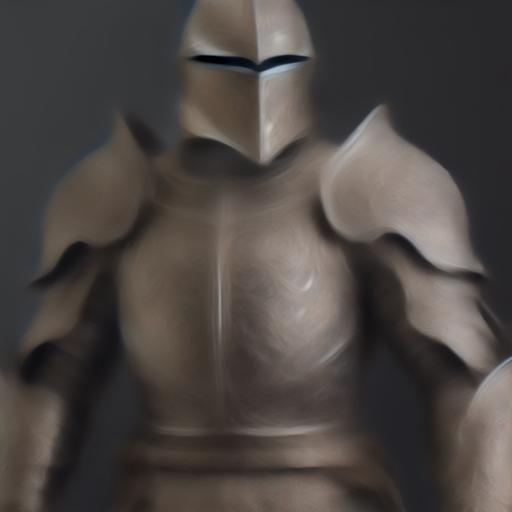Can you describe the attire of the person in the image? The person in the image is wearing what appears to be armor, possibly indicative of a knight or warrior. The armor has prominent shoulder plates, a solid breastplate, and a helmet with a narrow visor slit, although specific details are obscured due to the blurriness of the image. The attire suggests a medieval or fantasy theme. 